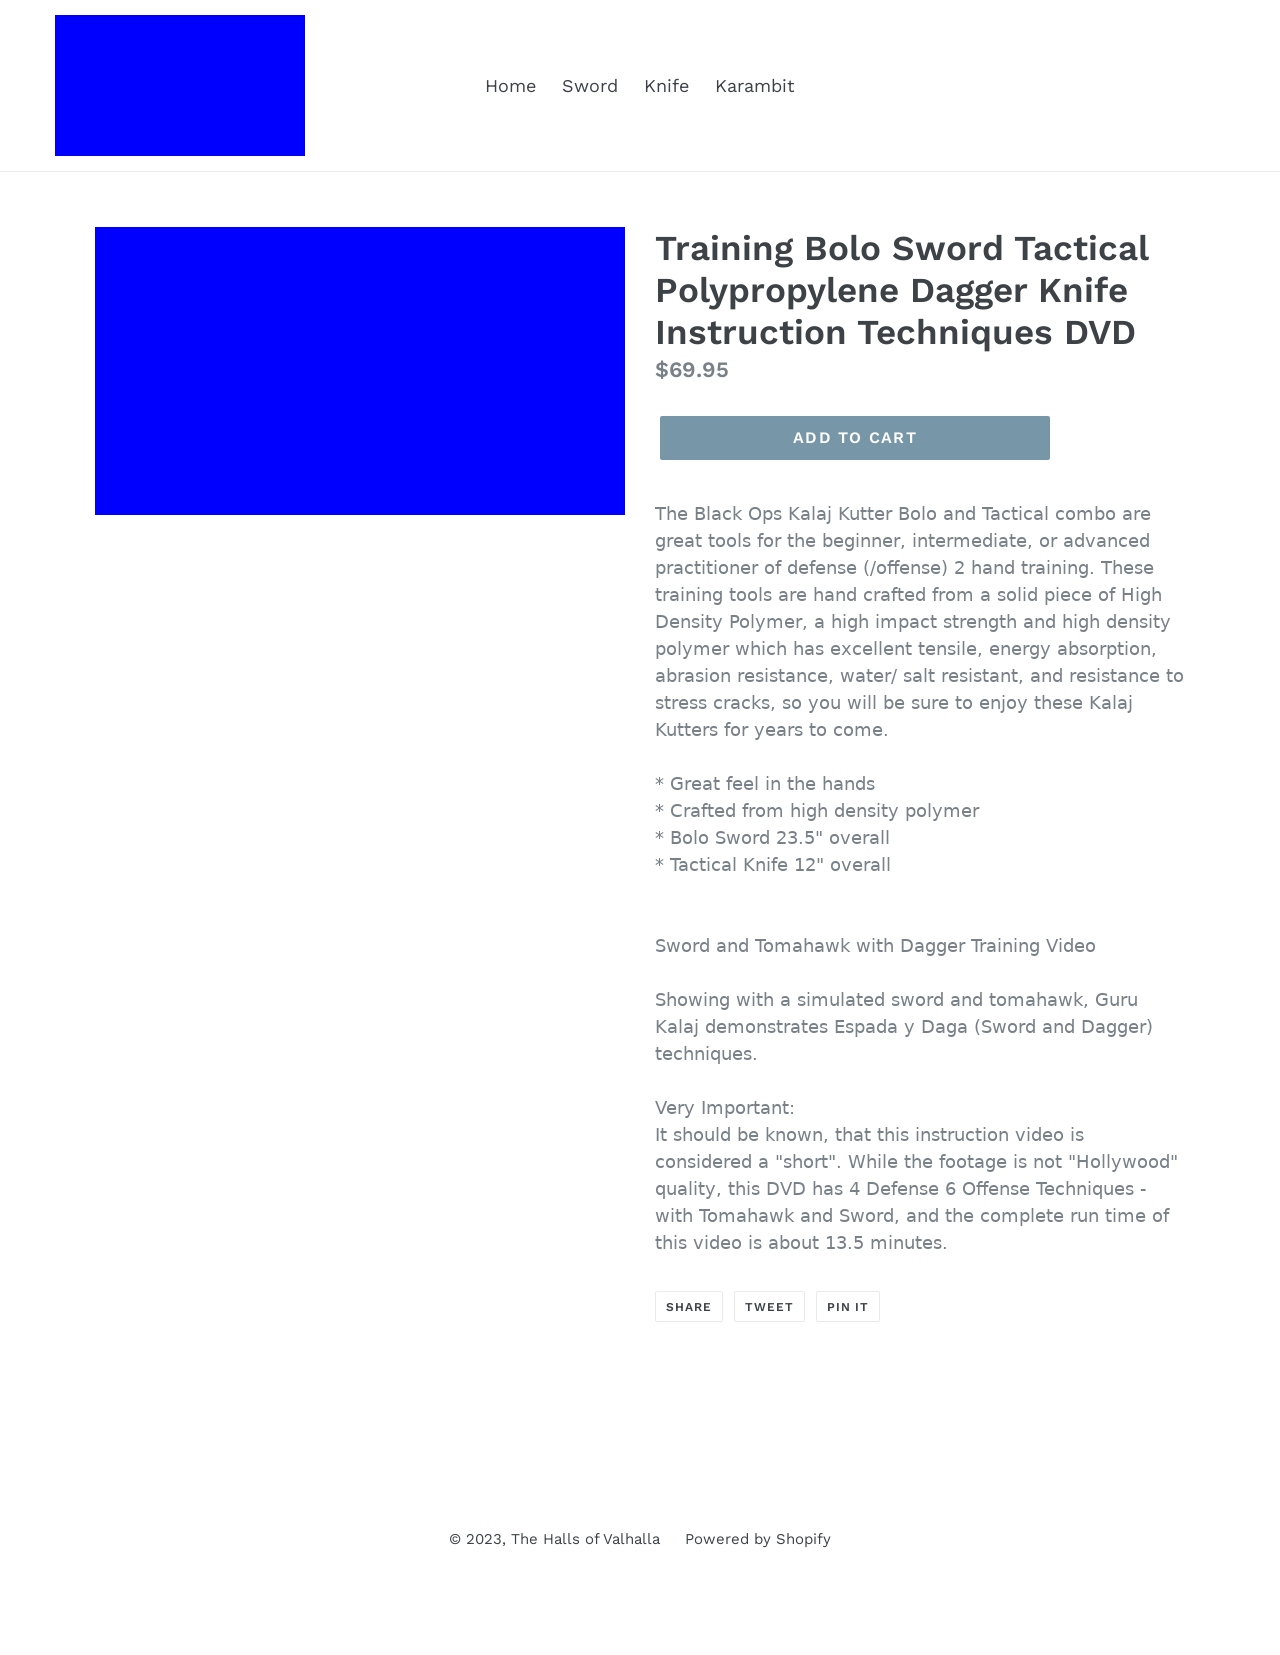Could you detail the process for assembling this website using HTML? The webpage for the Training Bolo Sword Tactical Polypropylene Dagger Knife is built using HTML5, CSS3, and potentially JavaScript for behavioral functions. The process involves structuring the page with semantic HTML tags, ensuring accessiblity through proper use of meta tags such as viewport for responsive design and content='' for improved search engine optimization. Styling is managed through linked CSS files and internal styles, which dictate the layout, fonts (like Work Sans), and other design elements, providing a visually appealing look aligned with the image's layout. JavaScript might be used to handle interactivity, such as responding to user clicks on 'Add to Cart' buttons or managing form submissions. 